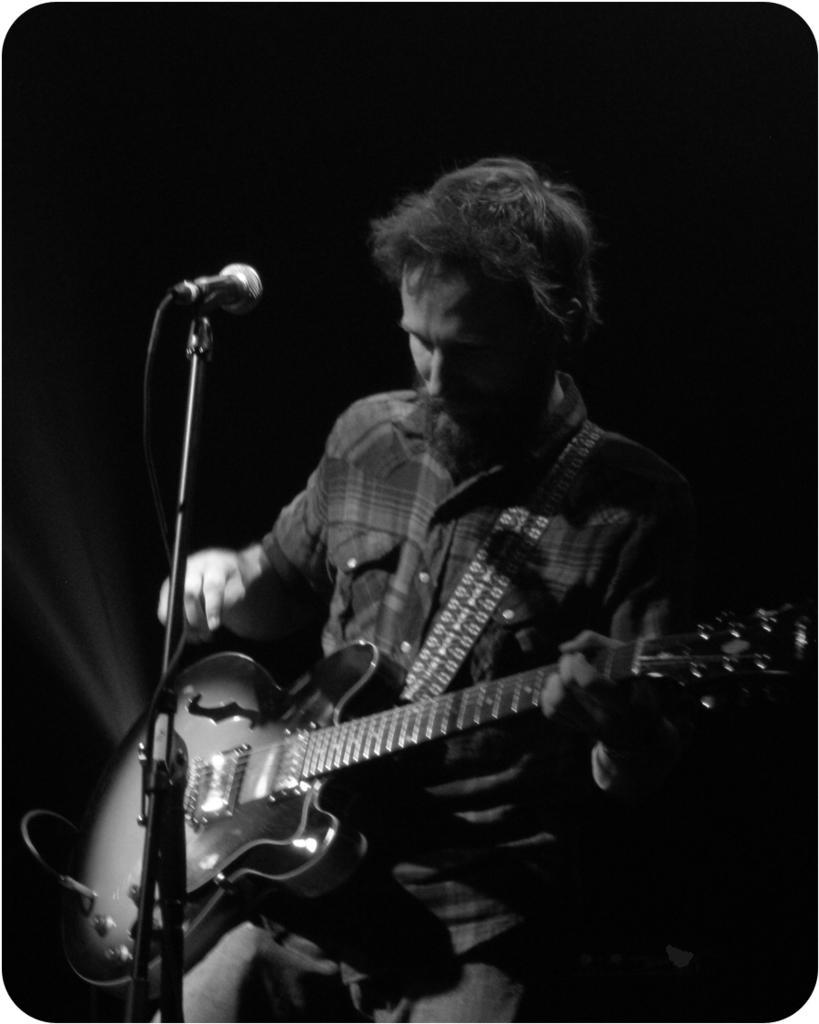Could you give a brief overview of what you see in this image? This is black and white picture in this picture the person is holding a guitar and moving the strings. In front of him there is a mic. 